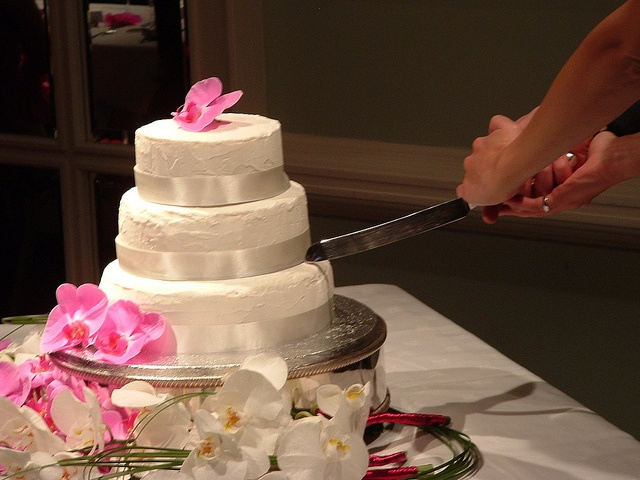Describe the objects in this image and their specific colors. I can see dining table in black, tan, and gray tones, cake in black, tan, and ivory tones, people in black, maroon, and brown tones, and knife in black, maroon, and gray tones in this image. 